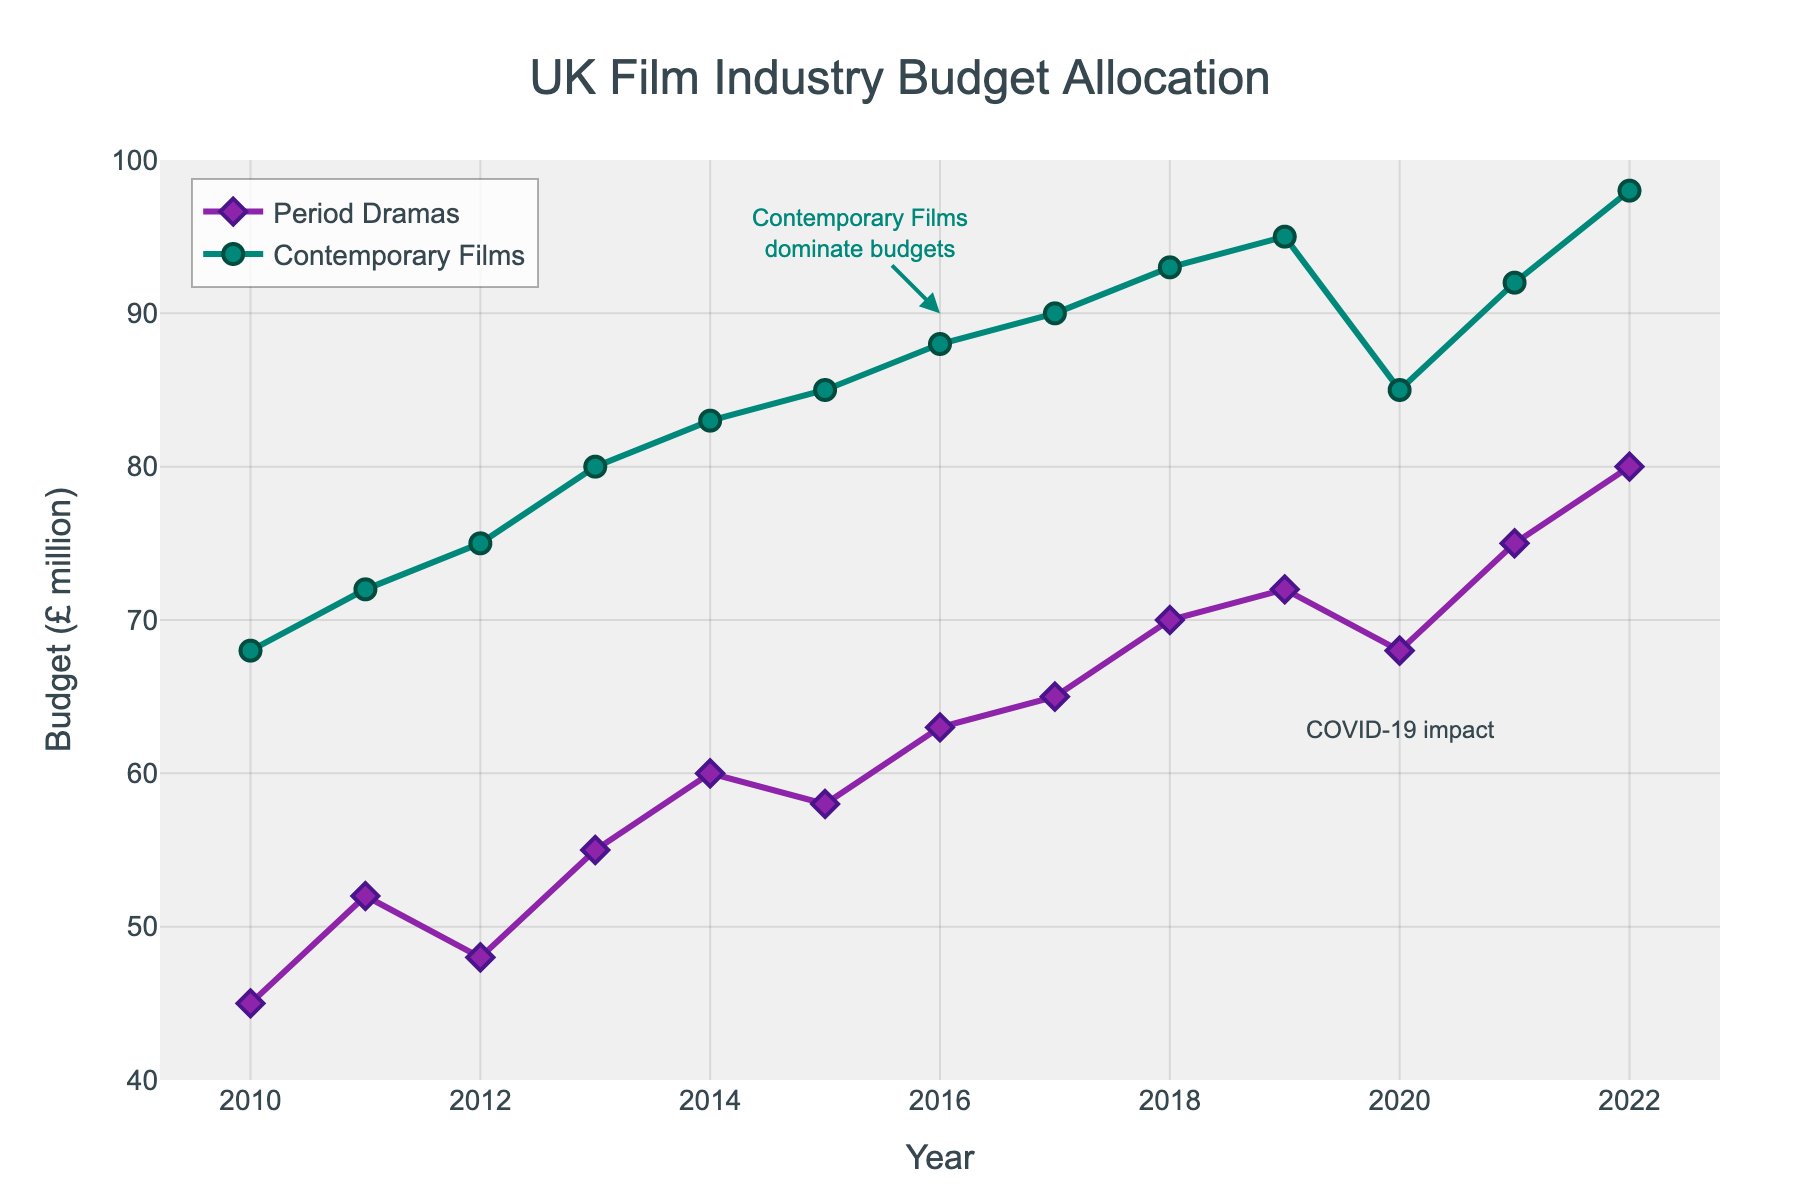What is the highest budget allocated for Contemporary Films? Look at the data points for the Contemporary Films Budget. The highest value is observed at the year 2022 with a budget of £98 million.
Answer: £98 million Which year saw the highest and lowest budget allocation for Period Dramas? Look at the data points for the Period Dramas Budget. The highest value is in 2022 with £80 million, and the lowest value is in 2010 with £45 million.
Answer: Highest: 2022, Lowest: 2010 In which year did the budget for Period Dramas surpass £60 million for the first time? Check the data points for Period Dramas Budget. The budget first surpasses £60 million in 2016 with a value of £63 million.
Answer: 2016 What is the average budget allocation for Contemporary Films from 2018 to 2022? Sum the budgets from 2018 to 2022 for Contemporary Films (£93 + £95 + £85 + £92 + £98 = £463) and divide by the number of years (5). The average budget is calculated as £463 / 5 = £92.6 million.
Answer: £92.6 million Compare the budget allocated to Period Dramas in 2020 and 2021 and state the percentage increase or decrease. The budget in 2020 is £68 million, and in 2021 it's £75 million. The percentage increase is calculated as ((75 - 68) / 68) * 100 ≈ 10.29%.
Answer: ≈ 10.29% increase Which year shows a notable dip in the budget for Contemporary Films, and what might be the reason according to the figure annotations? The year 2020 shows a notable dip in the budget for Contemporary Films (£85 million). According to the figure annotation, the reason might be the impact of COVID-19.
Answer: 2020, COVID-19 impact How do the trends of budget allocation for Period Dramas and Contemporary Films compare between 2015 and 2017? Observe the data points and trends for both categories between 2015 and 2017. Period Dramas budget increases from £58 million to £65 million, while Contemporary Films budget increases from £85 million to £90 million. Both categories show a positive trend but Contemporary Films have a consistently higher budget.
Answer: Both increased; Period Dramas from £58 million to £65 million, Contemporary Films from £85 million to £90 million What is the difference in budget allocation between Period Dramas and Contemporary Films in the year 2019? Subtract the budget of Period Dramas (£72 million) from the budget of Contemporary Films (£95 million) for the year 2019. The difference is £95 million - £72 million = £23 million.
Answer: £23 million How does the visual design indicate which genre dominates the budget allocation, and from which year does the annotation suggest this starts? The annotation on the figure states "Contemporary Films dominate budgets" around the year 2016, visually marked by an arrow and text. The green line representing Contemporary Films is consistently above the purple line for Period Dramas, indicating higher budgets.
Answer: Starts from 2016 What is the combined total budget for both genres in the year 2018? Sum the budgets of Period Dramas (£70 million) and Contemporary Films (£93 million) for the year 2018. The combined total budget is £70 million + £93 million = £163 million.
Answer: £163 million 